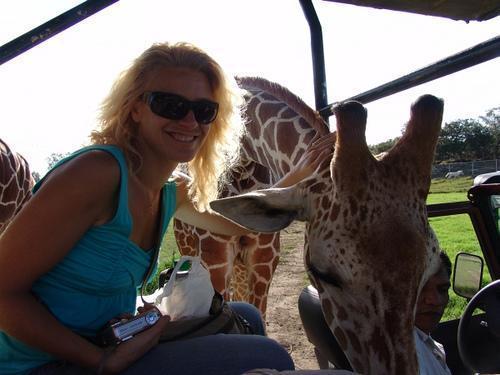How many giraffe heads are visible?
Give a very brief answer. 1. How many people are there?
Give a very brief answer. 1. How many giraffes are there?
Give a very brief answer. 2. How many people are in this picture?
Give a very brief answer. 1. How many mammals are in the photo?
Give a very brief answer. 3. 